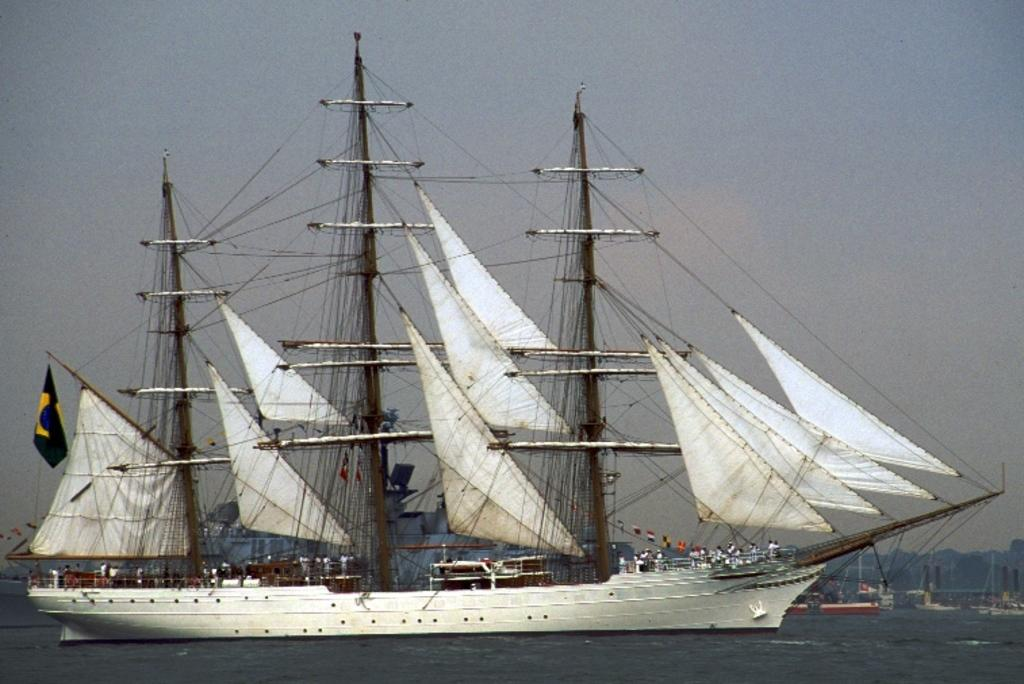What type of vehicles are present in the image? There are boats and a ship in the image. Where are the boats and ship located? They are on the water in the image. What can be seen on the ship? There are people standing in the ship. What is visible in the background of the image? Mountains and the sky are visible in the background of the image. What type of glove is being used to protect the ship from sleet in the image? There is no mention of sleet or gloves in the image; the focus is on the boats, ship, and people on the ship. 